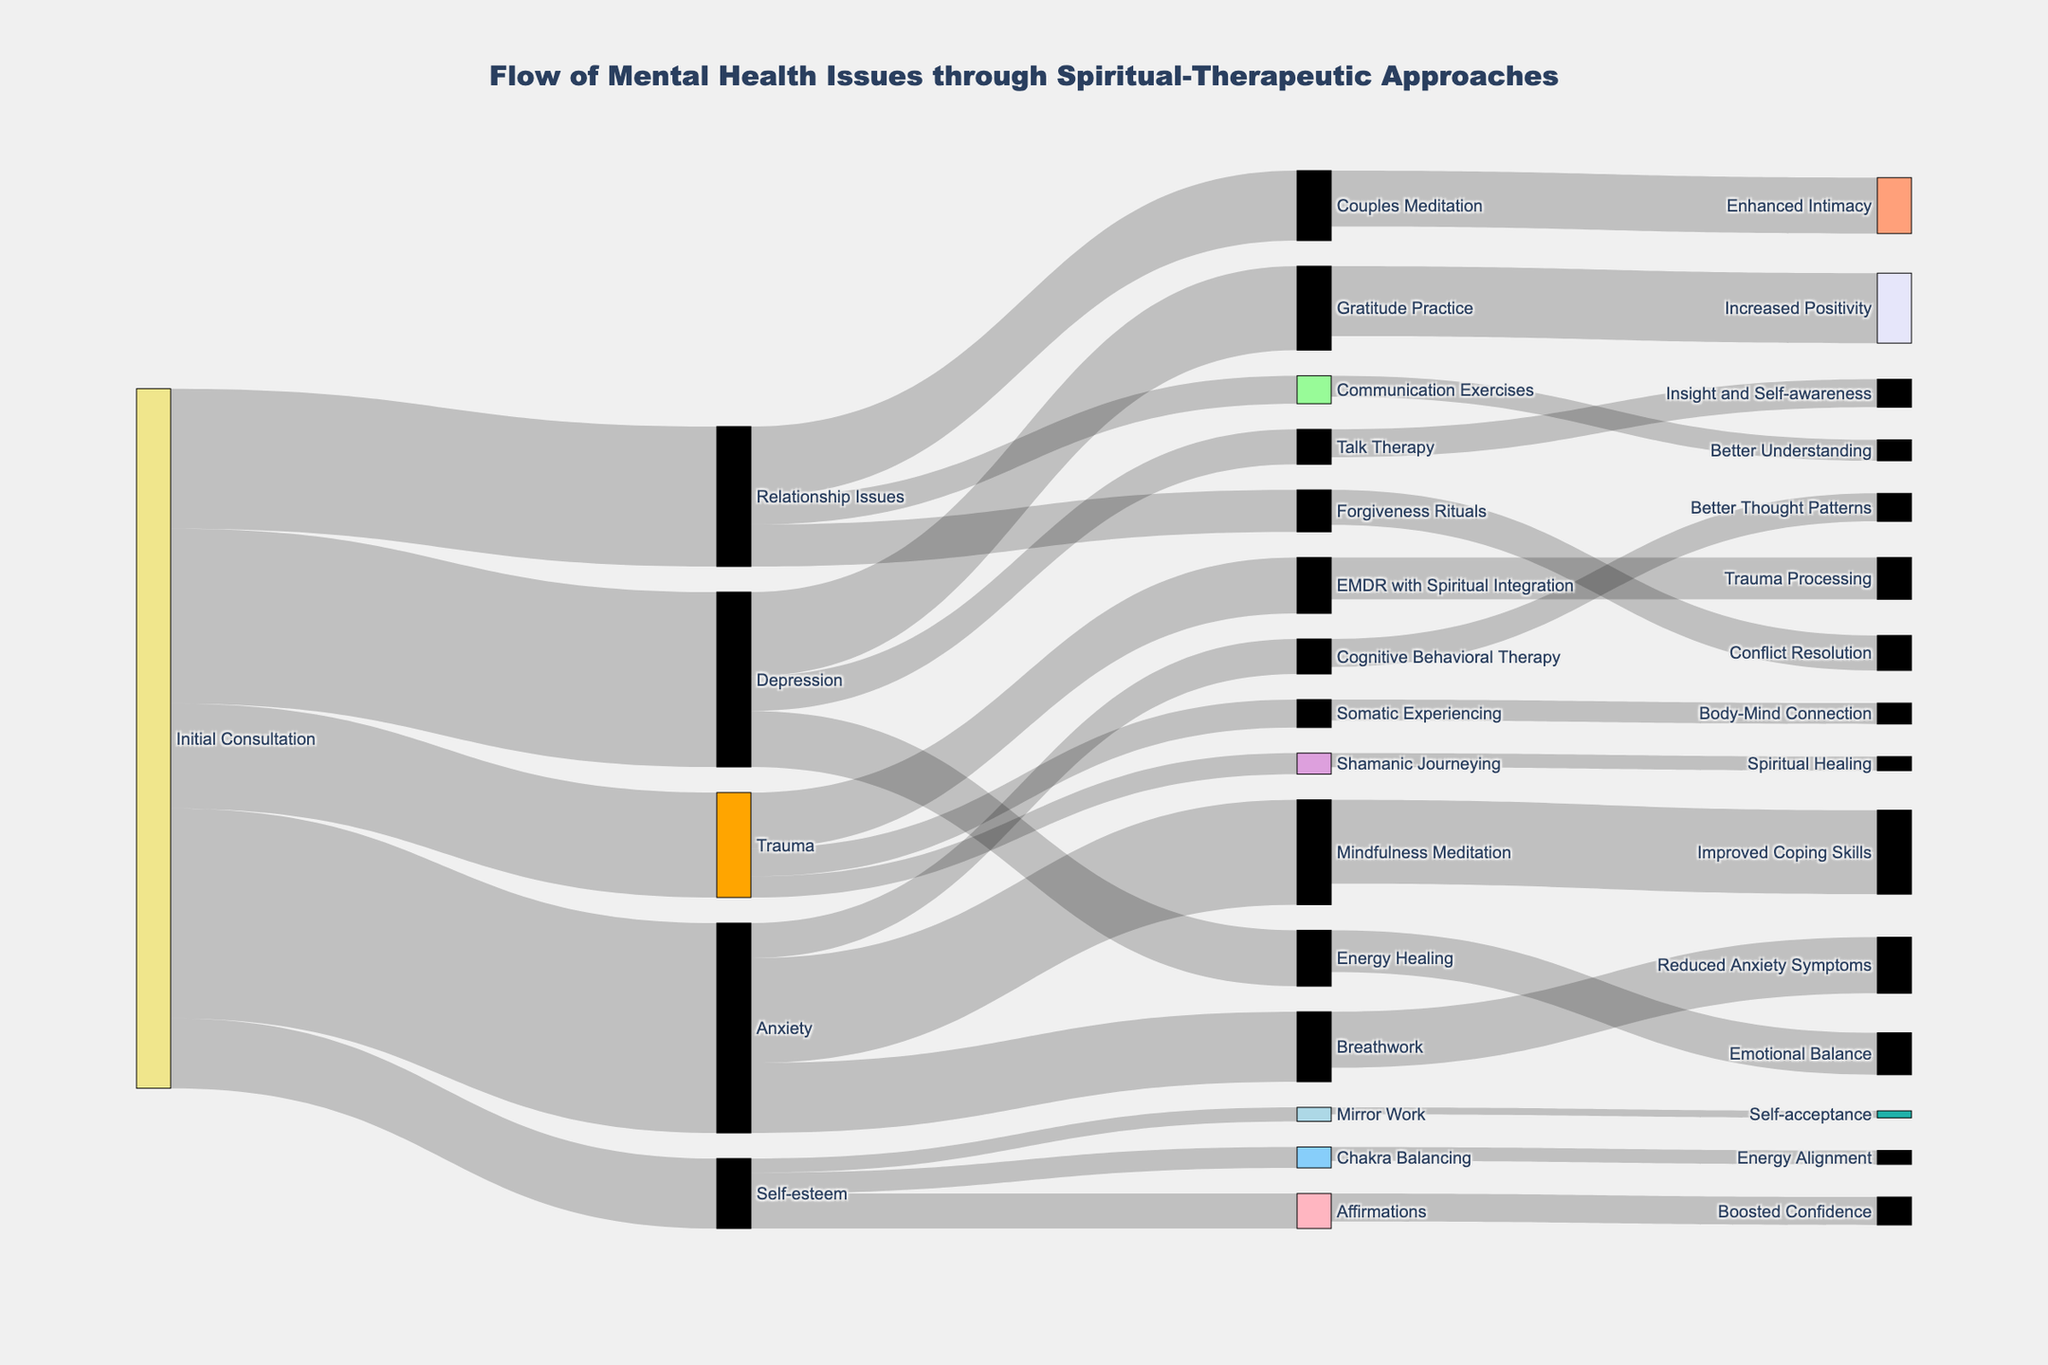What is the title of the Sankey Diagram? The title is usually displayed prominently at the top of the diagram.
Answer: Flow of Mental Health Issues through Spiritual-Therapeutic Approaches How many different mental health issues are addressed in the initial consultation stage? Count the unique targets linked to the "Initial Consultation" source node.
Answer: 5 Which spiritual-therapeutic approach is used most frequently for treating anxiety? Identify the target node linked to "Anxiety" with the highest value.
Answer: Mindfulness Meditation What is the total number of clients involved in the initial consultation? Sum the values of all targets linked to the "Initial Consultation" source node: 30 + 25 + 20 + 15 + 10.
Answer: 100 Which issue has the least number of clients at the initial consultation stage? Identify the target node linked to "Initial Consultation" with the smallest value.
Answer: Self-esteem What is the combined value of clients receiving Breathwork and Cognitive Behavioral Therapy for anxiety? Add the values of Breathwork and Cognitive Behavioral Therapy linked to Anxiety: 10 + 5.
Answer: 15 How many clients are treated with communication exercises for relationship issues? Check the value where the source is "Relationship Issues" and the target is "Communication Exercises".
Answer: 4 Which spiritual-therapeutic approach leads to emotional balance for clients with depression? Find the approach linked to "Depression" that leads to the outcome "Emotional Balance".
Answer: Energy Healing Is the number of clients using EMDR with spiritual integration higher or lower than those using Somatic Experiencing for trauma? Compare the values of EMDR with Spiritual Integration and Somatic Experiencing linked to Trauma.
Answer: Higher How many outcomes are connected to improved coping skills from Mindfulness Meditation? Count the number of target nodes linked to "Mindfulness Meditation".
Answer: 1 